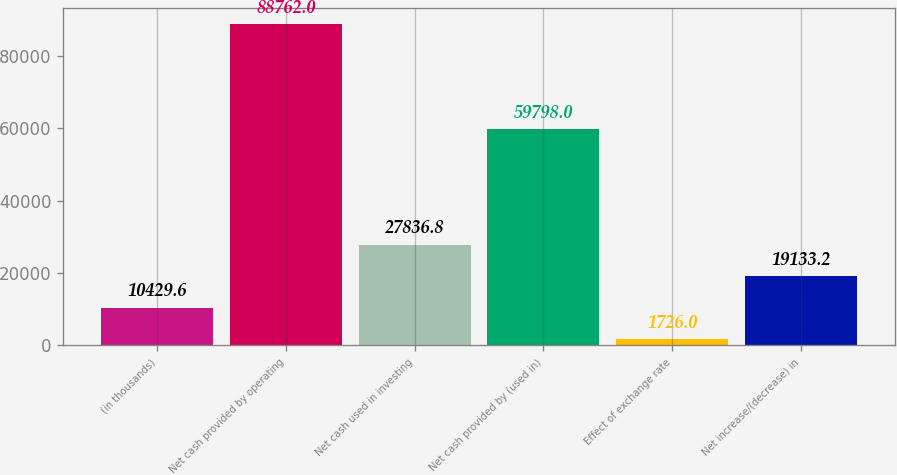Convert chart to OTSL. <chart><loc_0><loc_0><loc_500><loc_500><bar_chart><fcel>(in thousands)<fcel>Net cash provided by operating<fcel>Net cash used in investing<fcel>Net cash provided by (used in)<fcel>Effect of exchange rate<fcel>Net increase/(decrease) in<nl><fcel>10429.6<fcel>88762<fcel>27836.8<fcel>59798<fcel>1726<fcel>19133.2<nl></chart> 